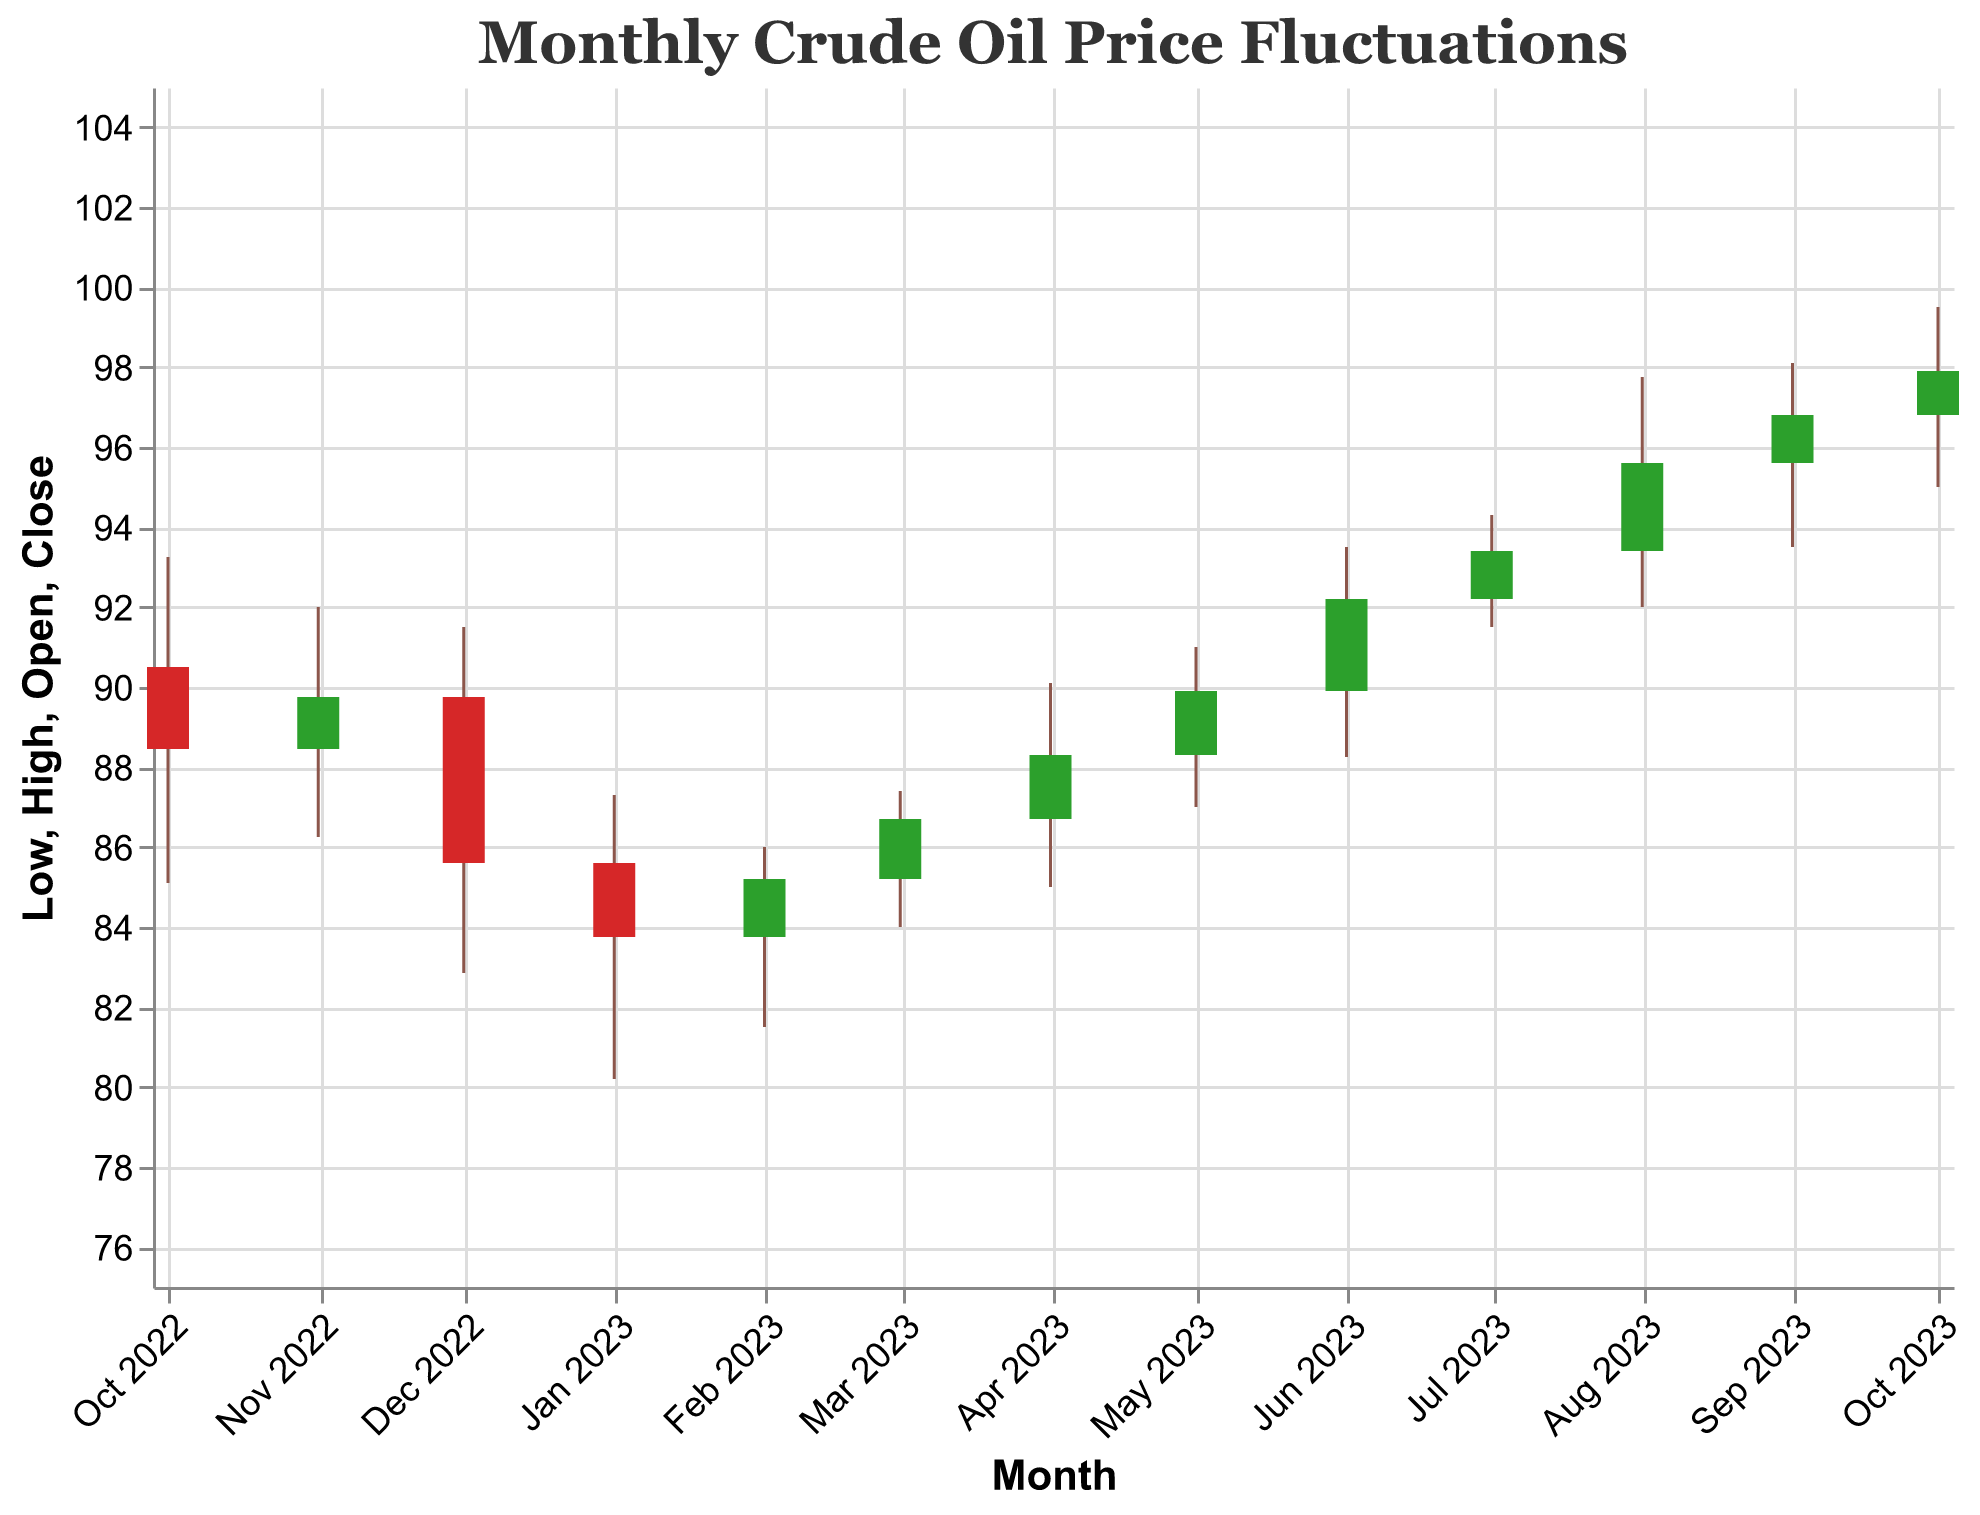What is the title of the plot? The title of the plot is typically located at the top of the chart and is clearly labeled.
Answer: Monthly Crude Oil Price Fluctuations What do the colors of the bars represent? Colors in the candlestick plot usually indicate whether the closing price was higher or lower than the opening price. Green bars indicate a rise (Close > Open) and red bars indicate a fall (Close < Open).
Answer: Rising and falling prices Which month had the highest closing price? To find the highest closing price, look at the top-end of each bar for every month and identify the tallest one.
Answer: October 2023 What is the range of crude oil prices in February 2023? The range of prices can be determined by finding the lowest and highest points represented for February 2023.
Answer: 81.50 to 86.00 Which month had the lowest low price in the year? Examine the bottom boundary of each candlestick to determine the lowest point.
Answer: December 2022 How many months have had closing prices higher than the opening prices? Look for the green bars, which indicate months where the closing price is higher than the opening price.
Answer: 7 months What is the difference between the opening and closing prices in July 2023? Subtract the closing price from the opening price for July 2023: 93.40 - 92.20 = 1.20.
Answer: 1.20 What was the opening price in May 2023? The opening price can be found at the lower boundary of the bar for the specified month.
Answer: 88.30 Between which months did the highest increase in closing prices occur? Calculate the difference in closing prices between consecutive months and find the pair with the highest positive difference. From August to September: 96.80 - 95.60 = 1.20, and from June to July: 93.40 - 92.20 = 1.20. The pair is August to September or June to July.
Answer: August and September 2023, or June and July 2023 Compare the high price in August 2023 and September 2023. Which one is higher? Compare the high price values for August and September. August has a high price of 97.75, whereas September has a high price of 98.10, so September's is higher.
Answer: September 2023 